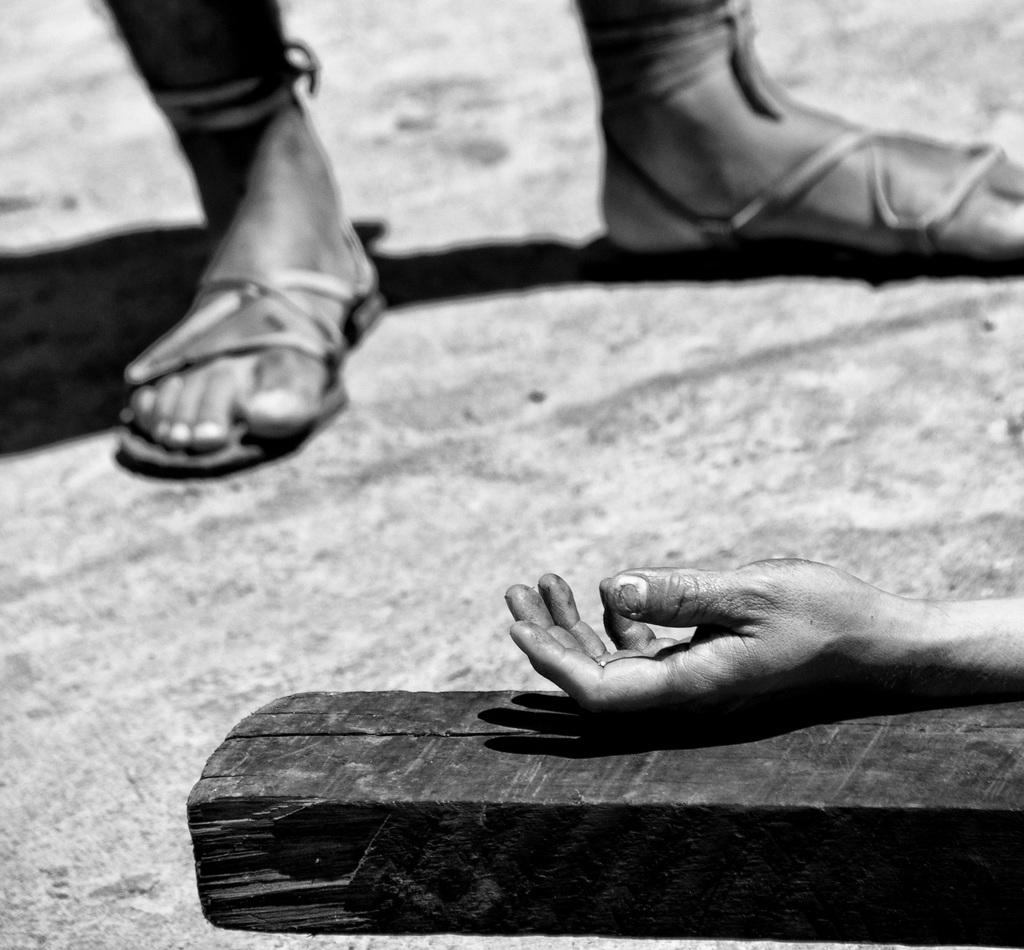What is the color scheme of the image? The image is black and white. What can be seen on the ground in the image? There is a person's hand on a wooden piece on the ground. What part of the person's body is visible besides their hand? The person's legs are visible in the image. What effect can be observed on the ground due to the person's presence? There is a shadow of the person's legs on the ground. What grade does the person in the image have in their wealth? The image does not provide any information about the person's wealth or grade, so it cannot be determined. What is the size of the person's shadow in the image? The size of the person's shadow cannot be determined from the image alone, as it depends on factors such as the person's height, the angle of the sun, and the distance between the person and the ground. 